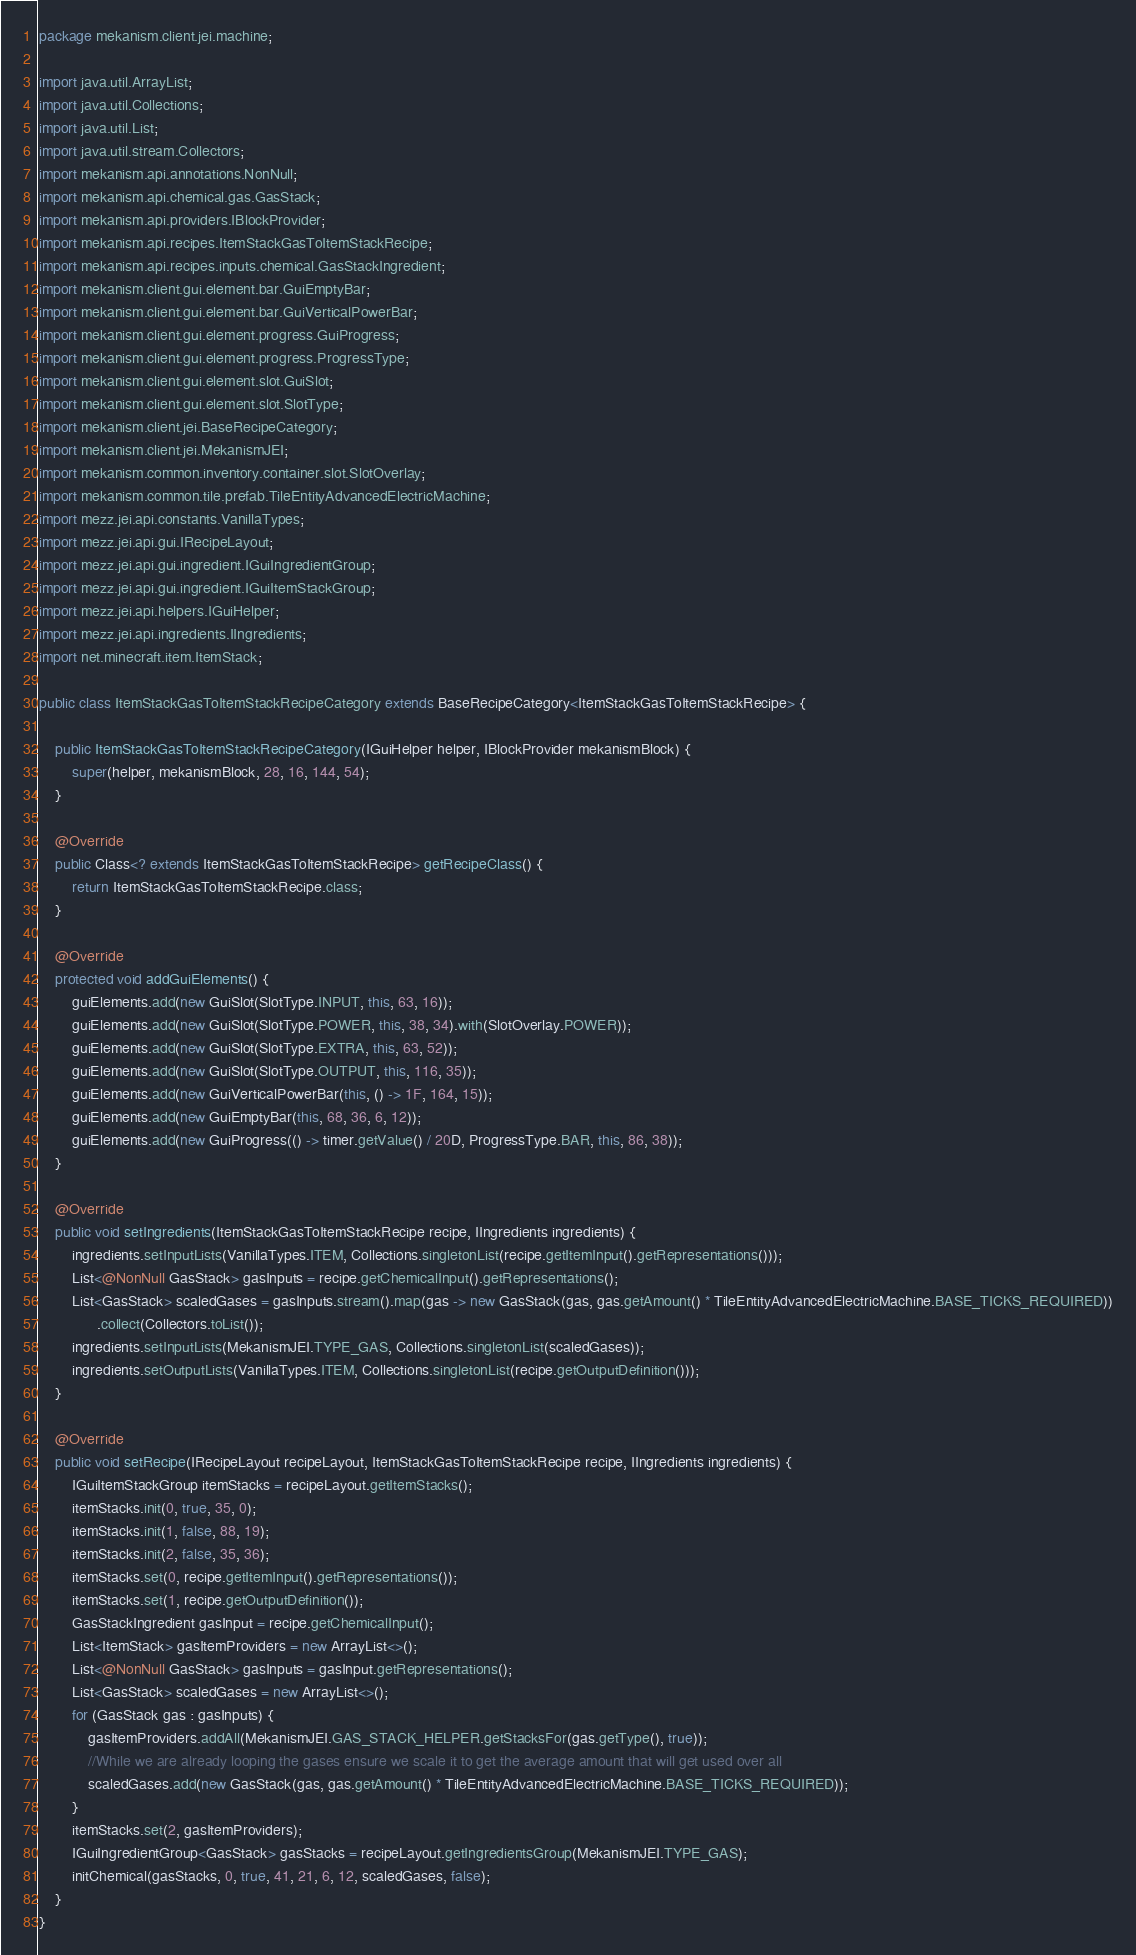Convert code to text. <code><loc_0><loc_0><loc_500><loc_500><_Java_>package mekanism.client.jei.machine;

import java.util.ArrayList;
import java.util.Collections;
import java.util.List;
import java.util.stream.Collectors;
import mekanism.api.annotations.NonNull;
import mekanism.api.chemical.gas.GasStack;
import mekanism.api.providers.IBlockProvider;
import mekanism.api.recipes.ItemStackGasToItemStackRecipe;
import mekanism.api.recipes.inputs.chemical.GasStackIngredient;
import mekanism.client.gui.element.bar.GuiEmptyBar;
import mekanism.client.gui.element.bar.GuiVerticalPowerBar;
import mekanism.client.gui.element.progress.GuiProgress;
import mekanism.client.gui.element.progress.ProgressType;
import mekanism.client.gui.element.slot.GuiSlot;
import mekanism.client.gui.element.slot.SlotType;
import mekanism.client.jei.BaseRecipeCategory;
import mekanism.client.jei.MekanismJEI;
import mekanism.common.inventory.container.slot.SlotOverlay;
import mekanism.common.tile.prefab.TileEntityAdvancedElectricMachine;
import mezz.jei.api.constants.VanillaTypes;
import mezz.jei.api.gui.IRecipeLayout;
import mezz.jei.api.gui.ingredient.IGuiIngredientGroup;
import mezz.jei.api.gui.ingredient.IGuiItemStackGroup;
import mezz.jei.api.helpers.IGuiHelper;
import mezz.jei.api.ingredients.IIngredients;
import net.minecraft.item.ItemStack;

public class ItemStackGasToItemStackRecipeCategory extends BaseRecipeCategory<ItemStackGasToItemStackRecipe> {

    public ItemStackGasToItemStackRecipeCategory(IGuiHelper helper, IBlockProvider mekanismBlock) {
        super(helper, mekanismBlock, 28, 16, 144, 54);
    }

    @Override
    public Class<? extends ItemStackGasToItemStackRecipe> getRecipeClass() {
        return ItemStackGasToItemStackRecipe.class;
    }

    @Override
    protected void addGuiElements() {
        guiElements.add(new GuiSlot(SlotType.INPUT, this, 63, 16));
        guiElements.add(new GuiSlot(SlotType.POWER, this, 38, 34).with(SlotOverlay.POWER));
        guiElements.add(new GuiSlot(SlotType.EXTRA, this, 63, 52));
        guiElements.add(new GuiSlot(SlotType.OUTPUT, this, 116, 35));
        guiElements.add(new GuiVerticalPowerBar(this, () -> 1F, 164, 15));
        guiElements.add(new GuiEmptyBar(this, 68, 36, 6, 12));
        guiElements.add(new GuiProgress(() -> timer.getValue() / 20D, ProgressType.BAR, this, 86, 38));
    }

    @Override
    public void setIngredients(ItemStackGasToItemStackRecipe recipe, IIngredients ingredients) {
        ingredients.setInputLists(VanillaTypes.ITEM, Collections.singletonList(recipe.getItemInput().getRepresentations()));
        List<@NonNull GasStack> gasInputs = recipe.getChemicalInput().getRepresentations();
        List<GasStack> scaledGases = gasInputs.stream().map(gas -> new GasStack(gas, gas.getAmount() * TileEntityAdvancedElectricMachine.BASE_TICKS_REQUIRED))
              .collect(Collectors.toList());
        ingredients.setInputLists(MekanismJEI.TYPE_GAS, Collections.singletonList(scaledGases));
        ingredients.setOutputLists(VanillaTypes.ITEM, Collections.singletonList(recipe.getOutputDefinition()));
    }

    @Override
    public void setRecipe(IRecipeLayout recipeLayout, ItemStackGasToItemStackRecipe recipe, IIngredients ingredients) {
        IGuiItemStackGroup itemStacks = recipeLayout.getItemStacks();
        itemStacks.init(0, true, 35, 0);
        itemStacks.init(1, false, 88, 19);
        itemStacks.init(2, false, 35, 36);
        itemStacks.set(0, recipe.getItemInput().getRepresentations());
        itemStacks.set(1, recipe.getOutputDefinition());
        GasStackIngredient gasInput = recipe.getChemicalInput();
        List<ItemStack> gasItemProviders = new ArrayList<>();
        List<@NonNull GasStack> gasInputs = gasInput.getRepresentations();
        List<GasStack> scaledGases = new ArrayList<>();
        for (GasStack gas : gasInputs) {
            gasItemProviders.addAll(MekanismJEI.GAS_STACK_HELPER.getStacksFor(gas.getType(), true));
            //While we are already looping the gases ensure we scale it to get the average amount that will get used over all
            scaledGases.add(new GasStack(gas, gas.getAmount() * TileEntityAdvancedElectricMachine.BASE_TICKS_REQUIRED));
        }
        itemStacks.set(2, gasItemProviders);
        IGuiIngredientGroup<GasStack> gasStacks = recipeLayout.getIngredientsGroup(MekanismJEI.TYPE_GAS);
        initChemical(gasStacks, 0, true, 41, 21, 6, 12, scaledGases, false);
    }
}</code> 